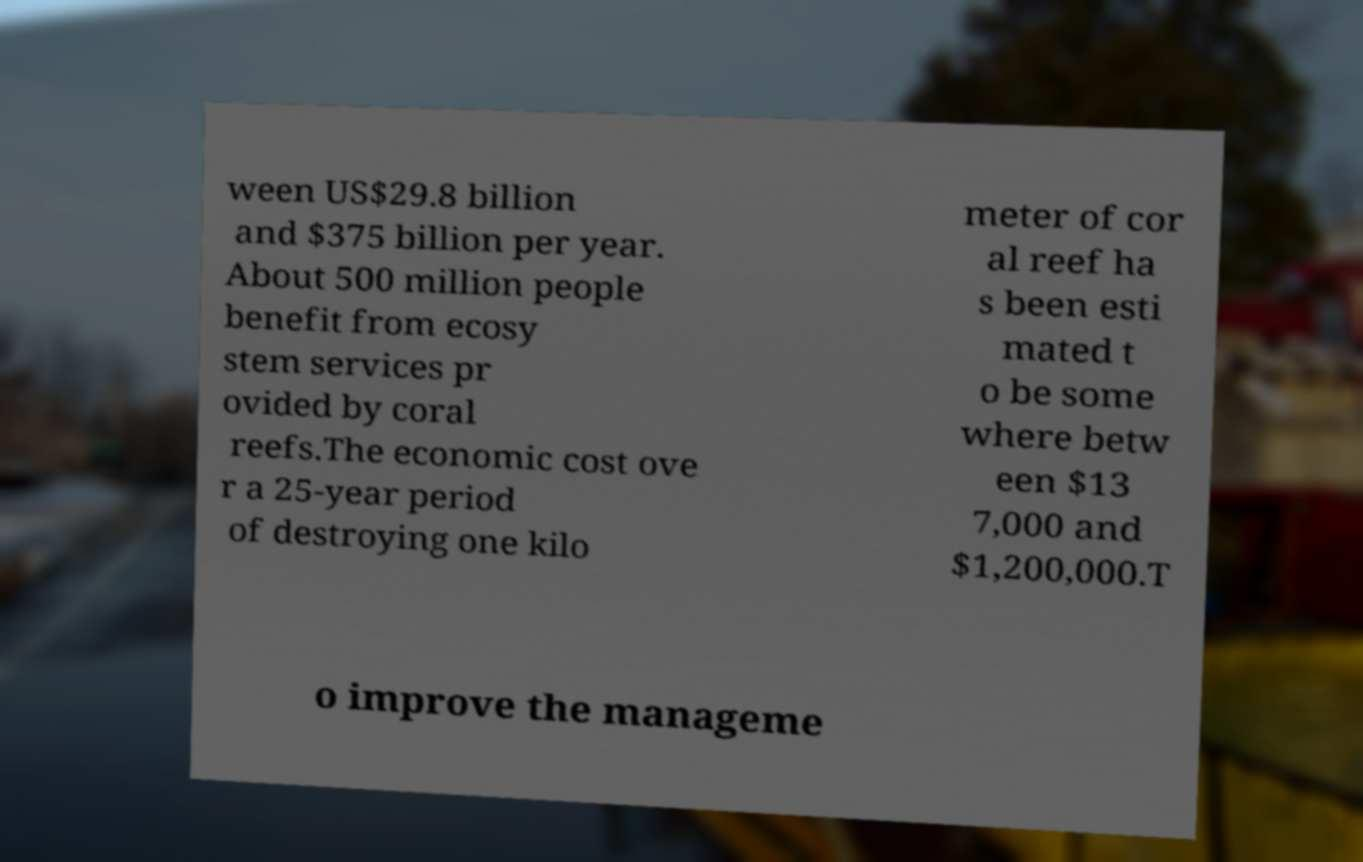Can you accurately transcribe the text from the provided image for me? ween US$29.8 billion and $375 billion per year. About 500 million people benefit from ecosy stem services pr ovided by coral reefs.The economic cost ove r a 25-year period of destroying one kilo meter of cor al reef ha s been esti mated t o be some where betw een $13 7,000 and $1,200,000.T o improve the manageme 